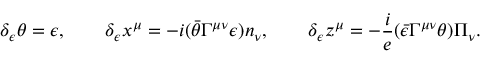Convert formula to latex. <formula><loc_0><loc_0><loc_500><loc_500>\delta _ { \epsilon } \theta = \epsilon , \quad \delta _ { \epsilon } x ^ { \mu } = - i ( \bar { \theta } \Gamma ^ { \mu \nu } \epsilon ) n _ { \nu } , \quad \delta _ { \epsilon } z ^ { \mu } = - \frac { i } { e } ( \bar { \epsilon } \Gamma ^ { \mu \nu } \theta ) \Pi _ { \nu } .</formula> 